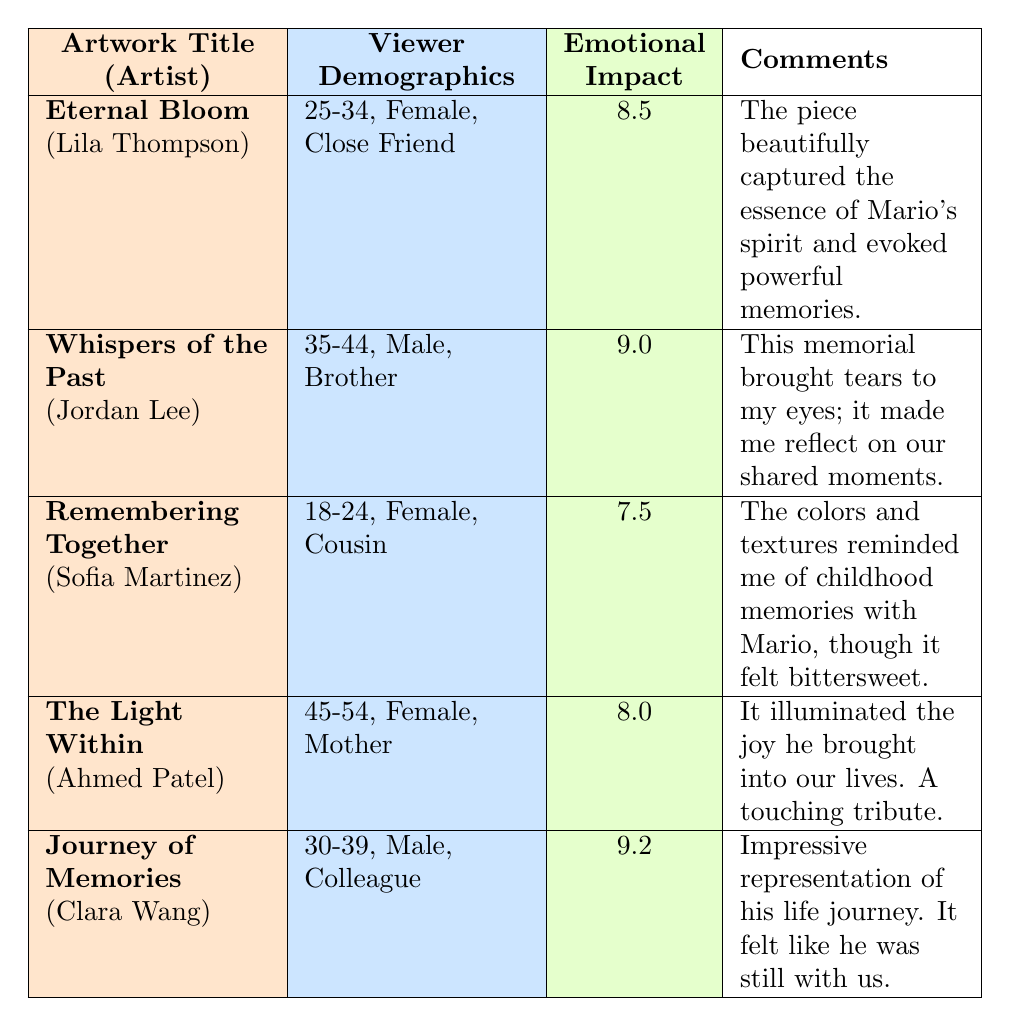What is the emotional impact rating of "Eternal Bloom"? The table shows "Eternal Bloom" with an emotional impact rating listed directly under that artwork title, which is 8.5.
Answer: 8.5 What demographic group is associated with the artwork "Journey of Memories"? The viewer demographics for "Journey of Memories" are specified in the table and indicate an age group of 30-39, Male, and relationship to the honoree as Colleague.
Answer: 30-39, Male, Colleague Which artwork received the highest emotional impact rating? Upon reviewing the emotional impact ratings listed in the table, "Journey of Memories" has the highest rating at 9.2, compared to the others.
Answer: Journey of Memories Is there a female artist in the survey? Looking through the table, we can find "Eternal Bloom" by Lila Thompson, "Remembering Together" by Sofia Martinez, and "The Light Within" by Ahmed Patel; hence, yes, there are female artists mentioned.
Answer: Yes What is the average emotional impact rating for all artworks? To find the average, first sum the ratings: 8.5 + 9.0 + 7.5 + 8.0 + 9.2 = 42.2. Then, divide by the number of artworks (5): 42.2 / 5 = 8.44.
Answer: 8.44 How many artworks are rated 8.0 or higher? The ratings of each artwork are analyzed: "Eternal Bloom" (8.5), "Whispers of the Past" (9.0), "Journey of Memories" (9.2), and "The Light Within" (8.0) meet this criterion, making a total of 4 artworks.
Answer: 4 Which viewer demographic had the lowest emotional impact rating and what was that rating? The demographic for "Remembering Together" at a rating of 7.5 is the lowest emotional impact rating listed, while the viewer demographic is 18-24, Female, Cousin.
Answer: 18-24, Female, Cousin; 7.5 Do all male viewers have a higher emotional impact rating than all female viewers? By assessing the emotional ratings for male viewers: "Whispers of the Past" (9.0) and "Journey of Memories" (9.2) average to 9.1, while female viewers: "Eternal Bloom" (8.5), "Remembering Together" (7.5), and "The Light Within" (8.0) average to 8.0. Therefore, males have a higher average.
Answer: Yes 